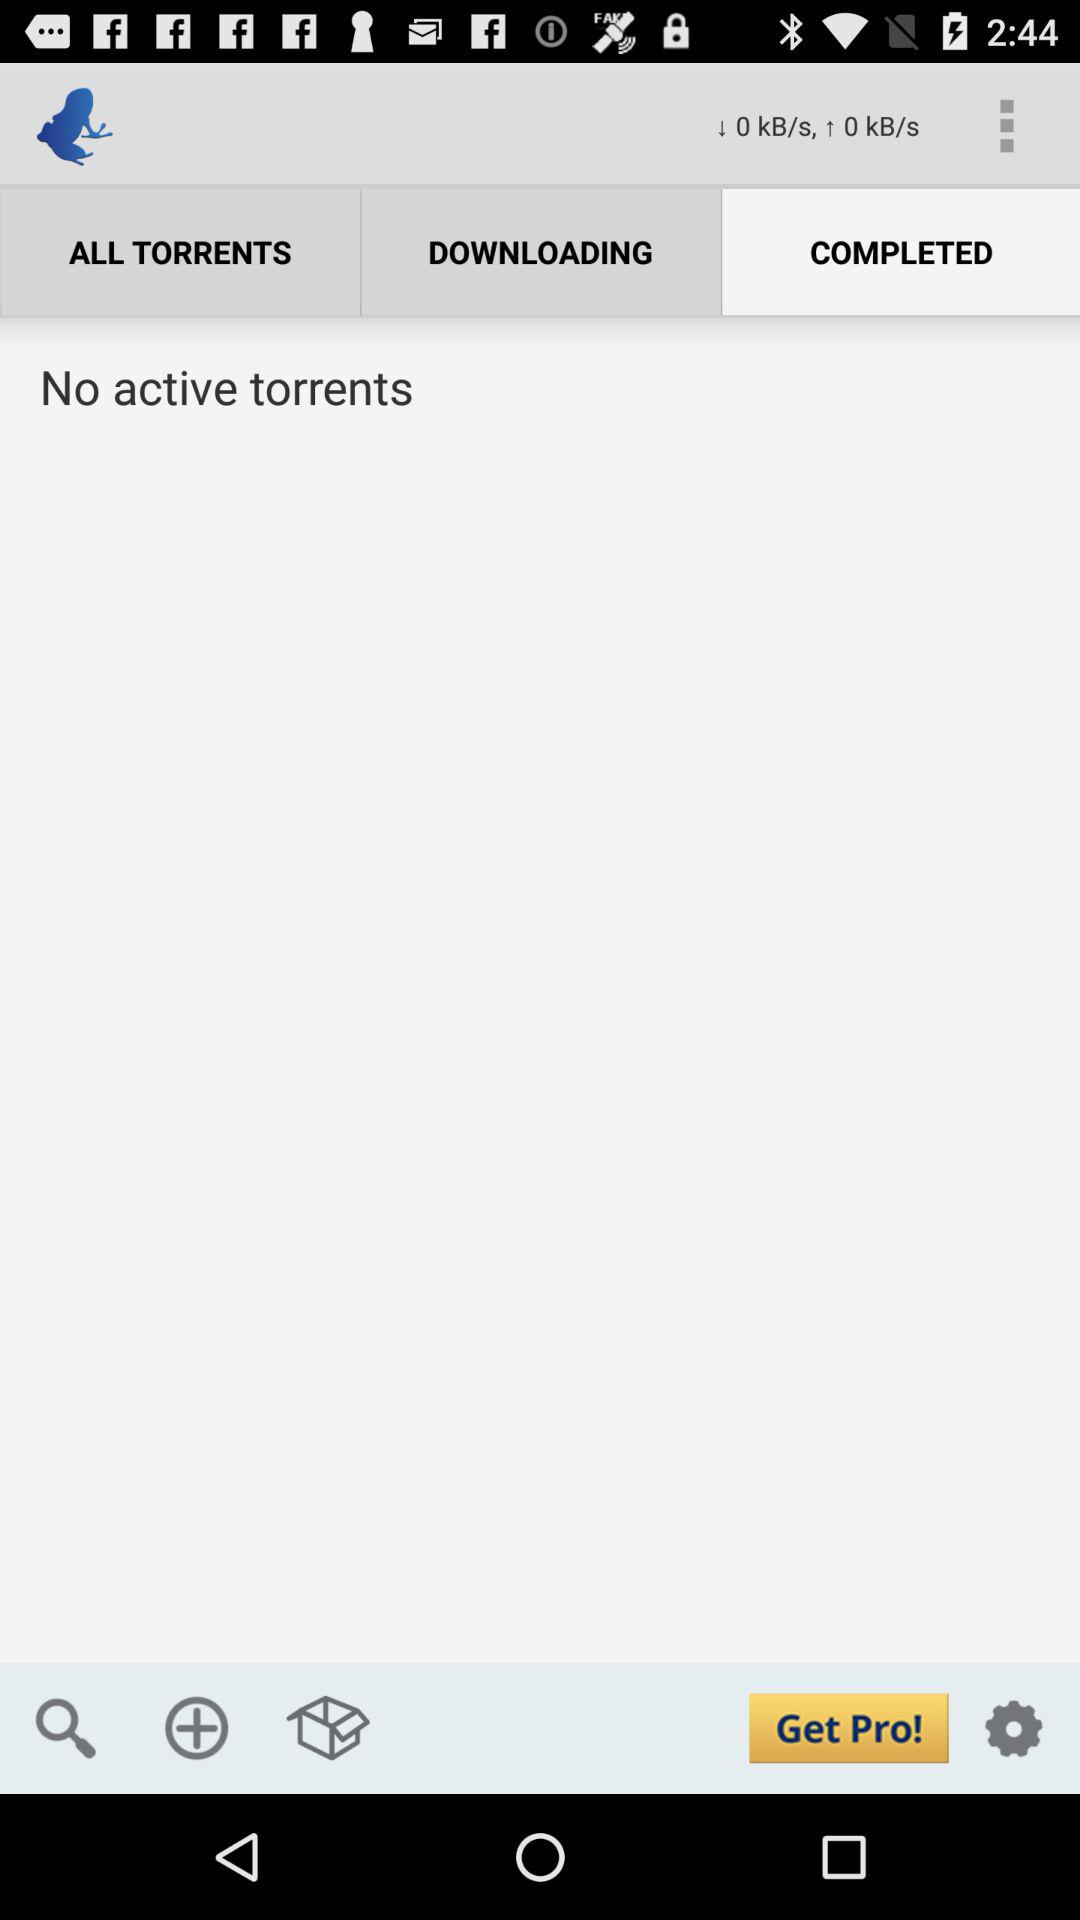What options are available in the bottom navigation of the app? At the bottom of the app, there are three navigation options. From left to right, they are a search icon, a plus icon possibly for adding new downloads, and a box icon which might relate to categories or organization of the torrents. 